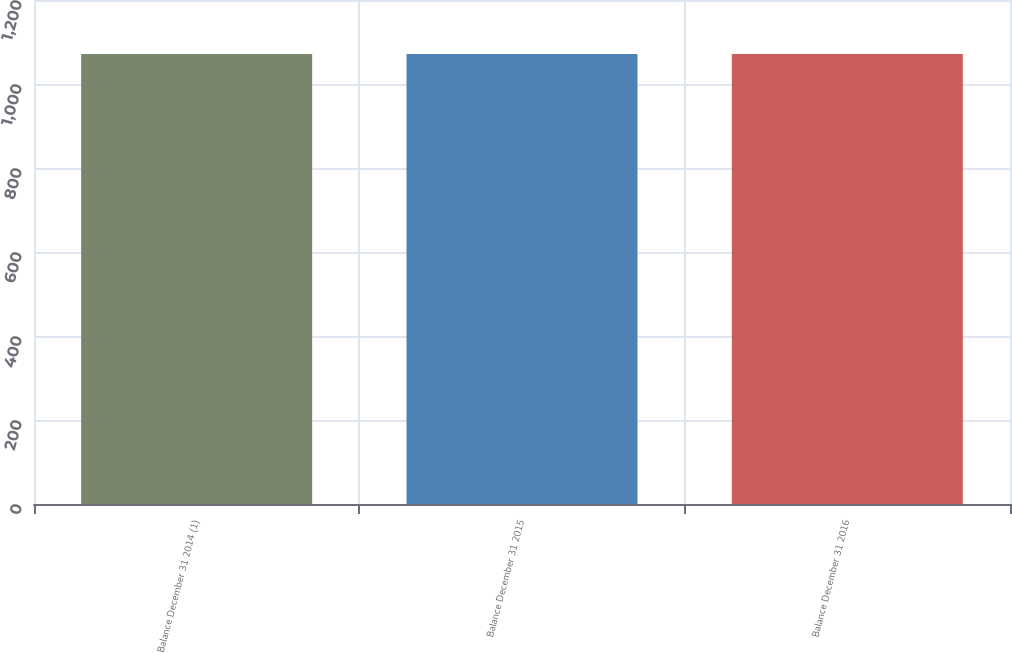Convert chart to OTSL. <chart><loc_0><loc_0><loc_500><loc_500><bar_chart><fcel>Balance December 31 2014 (1)<fcel>Balance December 31 2015<fcel>Balance December 31 2016<nl><fcel>1071.3<fcel>1071.4<fcel>1071.5<nl></chart> 